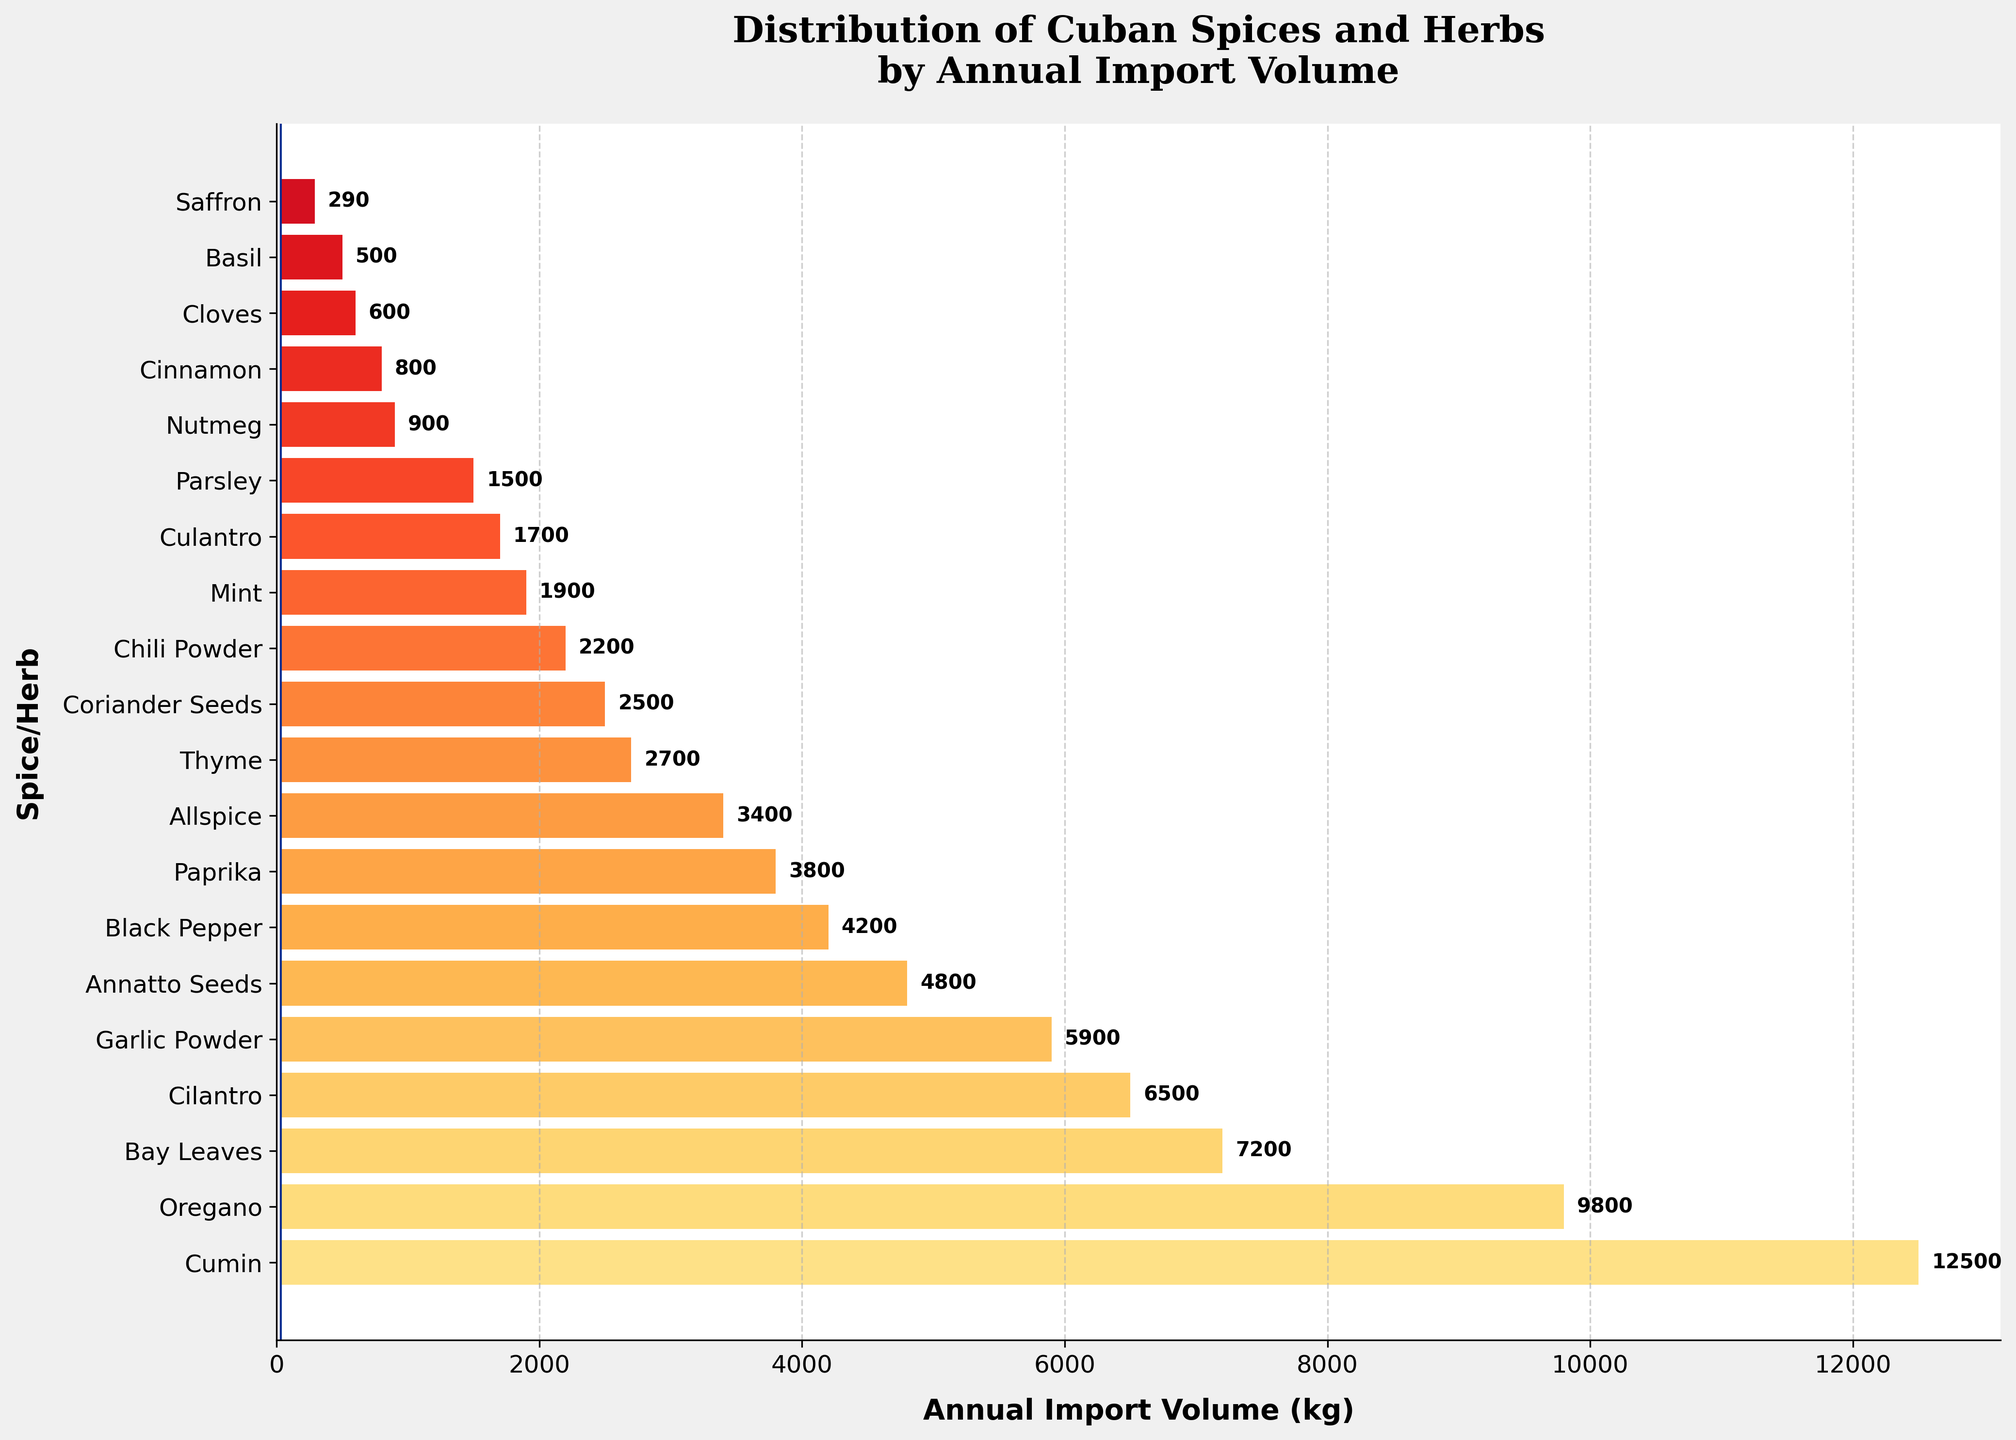Which spice or herb has the highest annual import volume? The highest bar on the chart represents the spice or herb with the highest annual import volume. In this case, it is clear that Cumin has the highest value.
Answer: Cumin Which two spices or herbs have nearly the same annual import volume? Looking at the lengths of the bars, Cilantro and Garlic Powder are very close in volume. Both are around the 5900 kg range.
Answer: Cilantro and Garlic Powder How much more cumin is imported annually than saffron? Cumin's import volume is 12500 kg and saffron's is 290 kg. Subtracting these gives 12500 - 290 = 12210 kg.
Answer: 12210 kg Which spice has the smallest annual import volume? The shortest bar represents the spice with the smallest volume. This spice is Basil.
Answer: Basil What is the combined annual import volume of Thyme and Cilantro? Thyme's volume is 2700 kg and Cilantro's is 6500 kg. Adding these gives 2700 + 6500 = 9200 kg.
Answer: 9200 kg Which spice or herb is imported more: Annatto Seeds or Black Pepper? Annatto Seeds have a volume of 4800 kg and Black Pepper has 4200 kg. Annatto Seeds have a longer bar.
Answer: Annatto Seeds Is Oregano imported in a larger volume than Bay Leaves? Oregano's bar is longer than Bay Leaves, and the import volumes (9800 kg for Oregano and 7200 kg for Bay Leaves) confirm this.
Answer: Yes What is the difference in annual import volume between the highest and lowest spice/herb? Cumin has the highest import volume (12500 kg) and Basil has the lowest (500 kg). The difference is 12500 - 500 = 12000 kg.
Answer: 12000 kg Based on the bar lengths, which spice or herb is roughly halfway between Cilantro and Paprika in volume? Cilantro is at 6500 kg and Paprika is at 3800 kg. The herb roughly halfway in volume is Annatto Seeds at 4800 kg.
Answer: Annatto Seeds What is the total annual import volume for all the herbs and spices combined? Summing all the import volumes: 12500 (Cumin) + 9800 (Oregano) + 7200 (Bay Leaves) + 6500 (Cilantro) + 5900 (Garlic Powder) + 4800 (Annatto Seeds) + 4200 (Black Pepper) + 3800 (Paprika) + 3400 (Allspice) + 290 (Saffron) + 2700 (Thyme) + 2500 (Coriander Seeds) + 2200 (Chili Powder) + 1900 (Mint) + 1700 (Culantro) + 1500 (Parsley) + 900 (Nutmeg) + 800 (Cinnamon) + 600 (Cloves) + 500 (Basil) = 77490 kg.
Answer: 77490 kg 